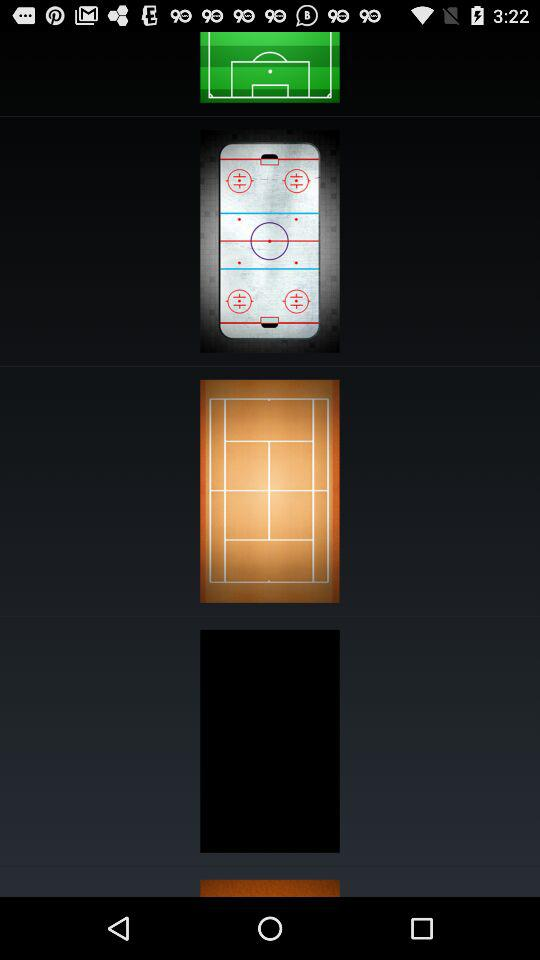How many sports are shown on this screen?
Answer the question using a single word or phrase. 3 